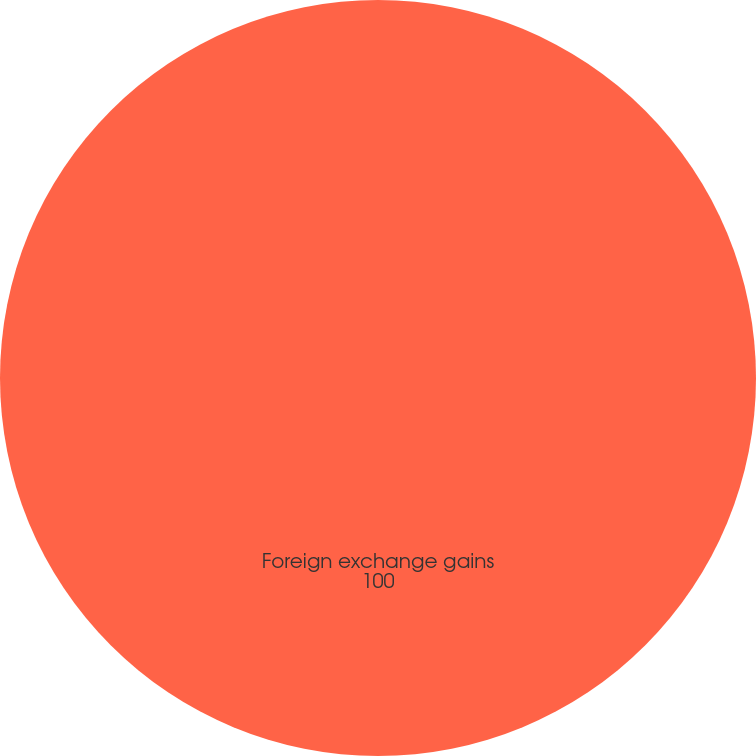<chart> <loc_0><loc_0><loc_500><loc_500><pie_chart><fcel>Foreign exchange gains<nl><fcel>100.0%<nl></chart> 